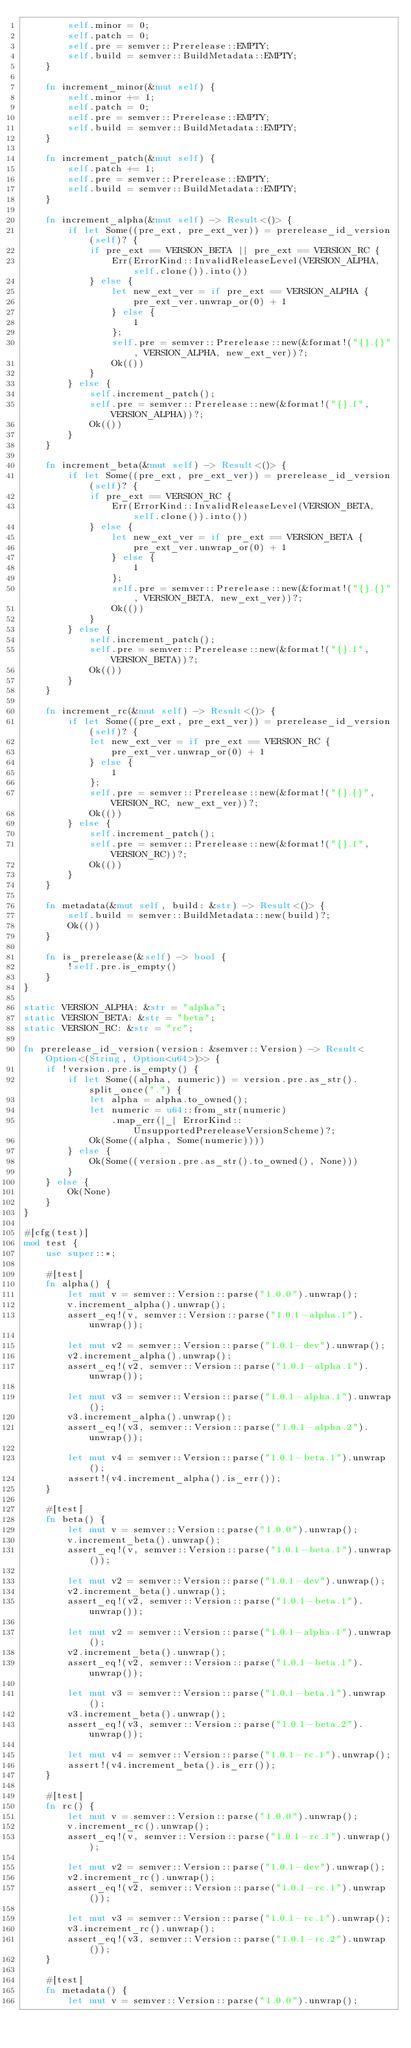Convert code to text. <code><loc_0><loc_0><loc_500><loc_500><_Rust_>        self.minor = 0;
        self.patch = 0;
        self.pre = semver::Prerelease::EMPTY;
        self.build = semver::BuildMetadata::EMPTY;
    }

    fn increment_minor(&mut self) {
        self.minor += 1;
        self.patch = 0;
        self.pre = semver::Prerelease::EMPTY;
        self.build = semver::BuildMetadata::EMPTY;
    }

    fn increment_patch(&mut self) {
        self.patch += 1;
        self.pre = semver::Prerelease::EMPTY;
        self.build = semver::BuildMetadata::EMPTY;
    }

    fn increment_alpha(&mut self) -> Result<()> {
        if let Some((pre_ext, pre_ext_ver)) = prerelease_id_version(self)? {
            if pre_ext == VERSION_BETA || pre_ext == VERSION_RC {
                Err(ErrorKind::InvalidReleaseLevel(VERSION_ALPHA, self.clone()).into())
            } else {
                let new_ext_ver = if pre_ext == VERSION_ALPHA {
                    pre_ext_ver.unwrap_or(0) + 1
                } else {
                    1
                };
                self.pre = semver::Prerelease::new(&format!("{}.{}", VERSION_ALPHA, new_ext_ver))?;
                Ok(())
            }
        } else {
            self.increment_patch();
            self.pre = semver::Prerelease::new(&format!("{}.1", VERSION_ALPHA))?;
            Ok(())
        }
    }

    fn increment_beta(&mut self) -> Result<()> {
        if let Some((pre_ext, pre_ext_ver)) = prerelease_id_version(self)? {
            if pre_ext == VERSION_RC {
                Err(ErrorKind::InvalidReleaseLevel(VERSION_BETA, self.clone()).into())
            } else {
                let new_ext_ver = if pre_ext == VERSION_BETA {
                    pre_ext_ver.unwrap_or(0) + 1
                } else {
                    1
                };
                self.pre = semver::Prerelease::new(&format!("{}.{}", VERSION_BETA, new_ext_ver))?;
                Ok(())
            }
        } else {
            self.increment_patch();
            self.pre = semver::Prerelease::new(&format!("{}.1", VERSION_BETA))?;
            Ok(())
        }
    }

    fn increment_rc(&mut self) -> Result<()> {
        if let Some((pre_ext, pre_ext_ver)) = prerelease_id_version(self)? {
            let new_ext_ver = if pre_ext == VERSION_RC {
                pre_ext_ver.unwrap_or(0) + 1
            } else {
                1
            };
            self.pre = semver::Prerelease::new(&format!("{}.{}", VERSION_RC, new_ext_ver))?;
            Ok(())
        } else {
            self.increment_patch();
            self.pre = semver::Prerelease::new(&format!("{}.1", VERSION_RC))?;
            Ok(())
        }
    }

    fn metadata(&mut self, build: &str) -> Result<()> {
        self.build = semver::BuildMetadata::new(build)?;
        Ok(())
    }

    fn is_prerelease(&self) -> bool {
        !self.pre.is_empty()
    }
}

static VERSION_ALPHA: &str = "alpha";
static VERSION_BETA: &str = "beta";
static VERSION_RC: &str = "rc";

fn prerelease_id_version(version: &semver::Version) -> Result<Option<(String, Option<u64>)>> {
    if !version.pre.is_empty() {
        if let Some((alpha, numeric)) = version.pre.as_str().split_once(".") {
            let alpha = alpha.to_owned();
            let numeric = u64::from_str(numeric)
                .map_err(|_| ErrorKind::UnsupportedPrereleaseVersionScheme)?;
            Ok(Some((alpha, Some(numeric))))
        } else {
            Ok(Some((version.pre.as_str().to_owned(), None)))
        }
    } else {
        Ok(None)
    }
}

#[cfg(test)]
mod test {
    use super::*;

    #[test]
    fn alpha() {
        let mut v = semver::Version::parse("1.0.0").unwrap();
        v.increment_alpha().unwrap();
        assert_eq!(v, semver::Version::parse("1.0.1-alpha.1").unwrap());

        let mut v2 = semver::Version::parse("1.0.1-dev").unwrap();
        v2.increment_alpha().unwrap();
        assert_eq!(v2, semver::Version::parse("1.0.1-alpha.1").unwrap());

        let mut v3 = semver::Version::parse("1.0.1-alpha.1").unwrap();
        v3.increment_alpha().unwrap();
        assert_eq!(v3, semver::Version::parse("1.0.1-alpha.2").unwrap());

        let mut v4 = semver::Version::parse("1.0.1-beta.1").unwrap();
        assert!(v4.increment_alpha().is_err());
    }

    #[test]
    fn beta() {
        let mut v = semver::Version::parse("1.0.0").unwrap();
        v.increment_beta().unwrap();
        assert_eq!(v, semver::Version::parse("1.0.1-beta.1").unwrap());

        let mut v2 = semver::Version::parse("1.0.1-dev").unwrap();
        v2.increment_beta().unwrap();
        assert_eq!(v2, semver::Version::parse("1.0.1-beta.1").unwrap());

        let mut v2 = semver::Version::parse("1.0.1-alpha.1").unwrap();
        v2.increment_beta().unwrap();
        assert_eq!(v2, semver::Version::parse("1.0.1-beta.1").unwrap());

        let mut v3 = semver::Version::parse("1.0.1-beta.1").unwrap();
        v3.increment_beta().unwrap();
        assert_eq!(v3, semver::Version::parse("1.0.1-beta.2").unwrap());

        let mut v4 = semver::Version::parse("1.0.1-rc.1").unwrap();
        assert!(v4.increment_beta().is_err());
    }

    #[test]
    fn rc() {
        let mut v = semver::Version::parse("1.0.0").unwrap();
        v.increment_rc().unwrap();
        assert_eq!(v, semver::Version::parse("1.0.1-rc.1").unwrap());

        let mut v2 = semver::Version::parse("1.0.1-dev").unwrap();
        v2.increment_rc().unwrap();
        assert_eq!(v2, semver::Version::parse("1.0.1-rc.1").unwrap());

        let mut v3 = semver::Version::parse("1.0.1-rc.1").unwrap();
        v3.increment_rc().unwrap();
        assert_eq!(v3, semver::Version::parse("1.0.1-rc.2").unwrap());
    }

    #[test]
    fn metadata() {
        let mut v = semver::Version::parse("1.0.0").unwrap();</code> 